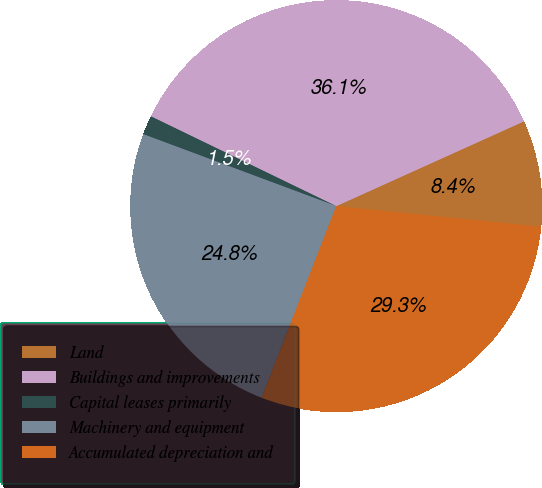Convert chart. <chart><loc_0><loc_0><loc_500><loc_500><pie_chart><fcel>Land<fcel>Buildings and improvements<fcel>Capital leases primarily<fcel>Machinery and equipment<fcel>Accumulated depreciation and<nl><fcel>8.35%<fcel>36.07%<fcel>1.5%<fcel>24.76%<fcel>29.32%<nl></chart> 